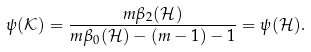<formula> <loc_0><loc_0><loc_500><loc_500>\psi ( { \mathcal { K } } ) = \frac { m \beta _ { 2 } ( { \mathcal { H } } ) } { m \beta _ { 0 } ( { \mathcal { H } } ) - ( m - 1 ) - 1 } = \psi ( { \mathcal { H } } ) .</formula> 